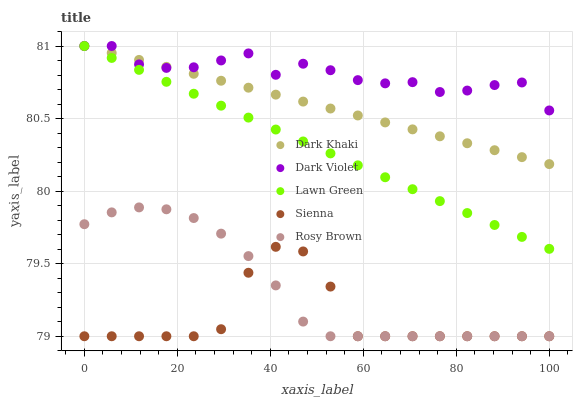Does Sienna have the minimum area under the curve?
Answer yes or no. Yes. Does Dark Violet have the maximum area under the curve?
Answer yes or no. Yes. Does Lawn Green have the minimum area under the curve?
Answer yes or no. No. Does Lawn Green have the maximum area under the curve?
Answer yes or no. No. Is Lawn Green the smoothest?
Answer yes or no. Yes. Is Sienna the roughest?
Answer yes or no. Yes. Is Rosy Brown the smoothest?
Answer yes or no. No. Is Rosy Brown the roughest?
Answer yes or no. No. Does Rosy Brown have the lowest value?
Answer yes or no. Yes. Does Lawn Green have the lowest value?
Answer yes or no. No. Does Dark Violet have the highest value?
Answer yes or no. Yes. Does Rosy Brown have the highest value?
Answer yes or no. No. Is Sienna less than Dark Khaki?
Answer yes or no. Yes. Is Dark Violet greater than Sienna?
Answer yes or no. Yes. Does Dark Violet intersect Dark Khaki?
Answer yes or no. Yes. Is Dark Violet less than Dark Khaki?
Answer yes or no. No. Is Dark Violet greater than Dark Khaki?
Answer yes or no. No. Does Sienna intersect Dark Khaki?
Answer yes or no. No. 